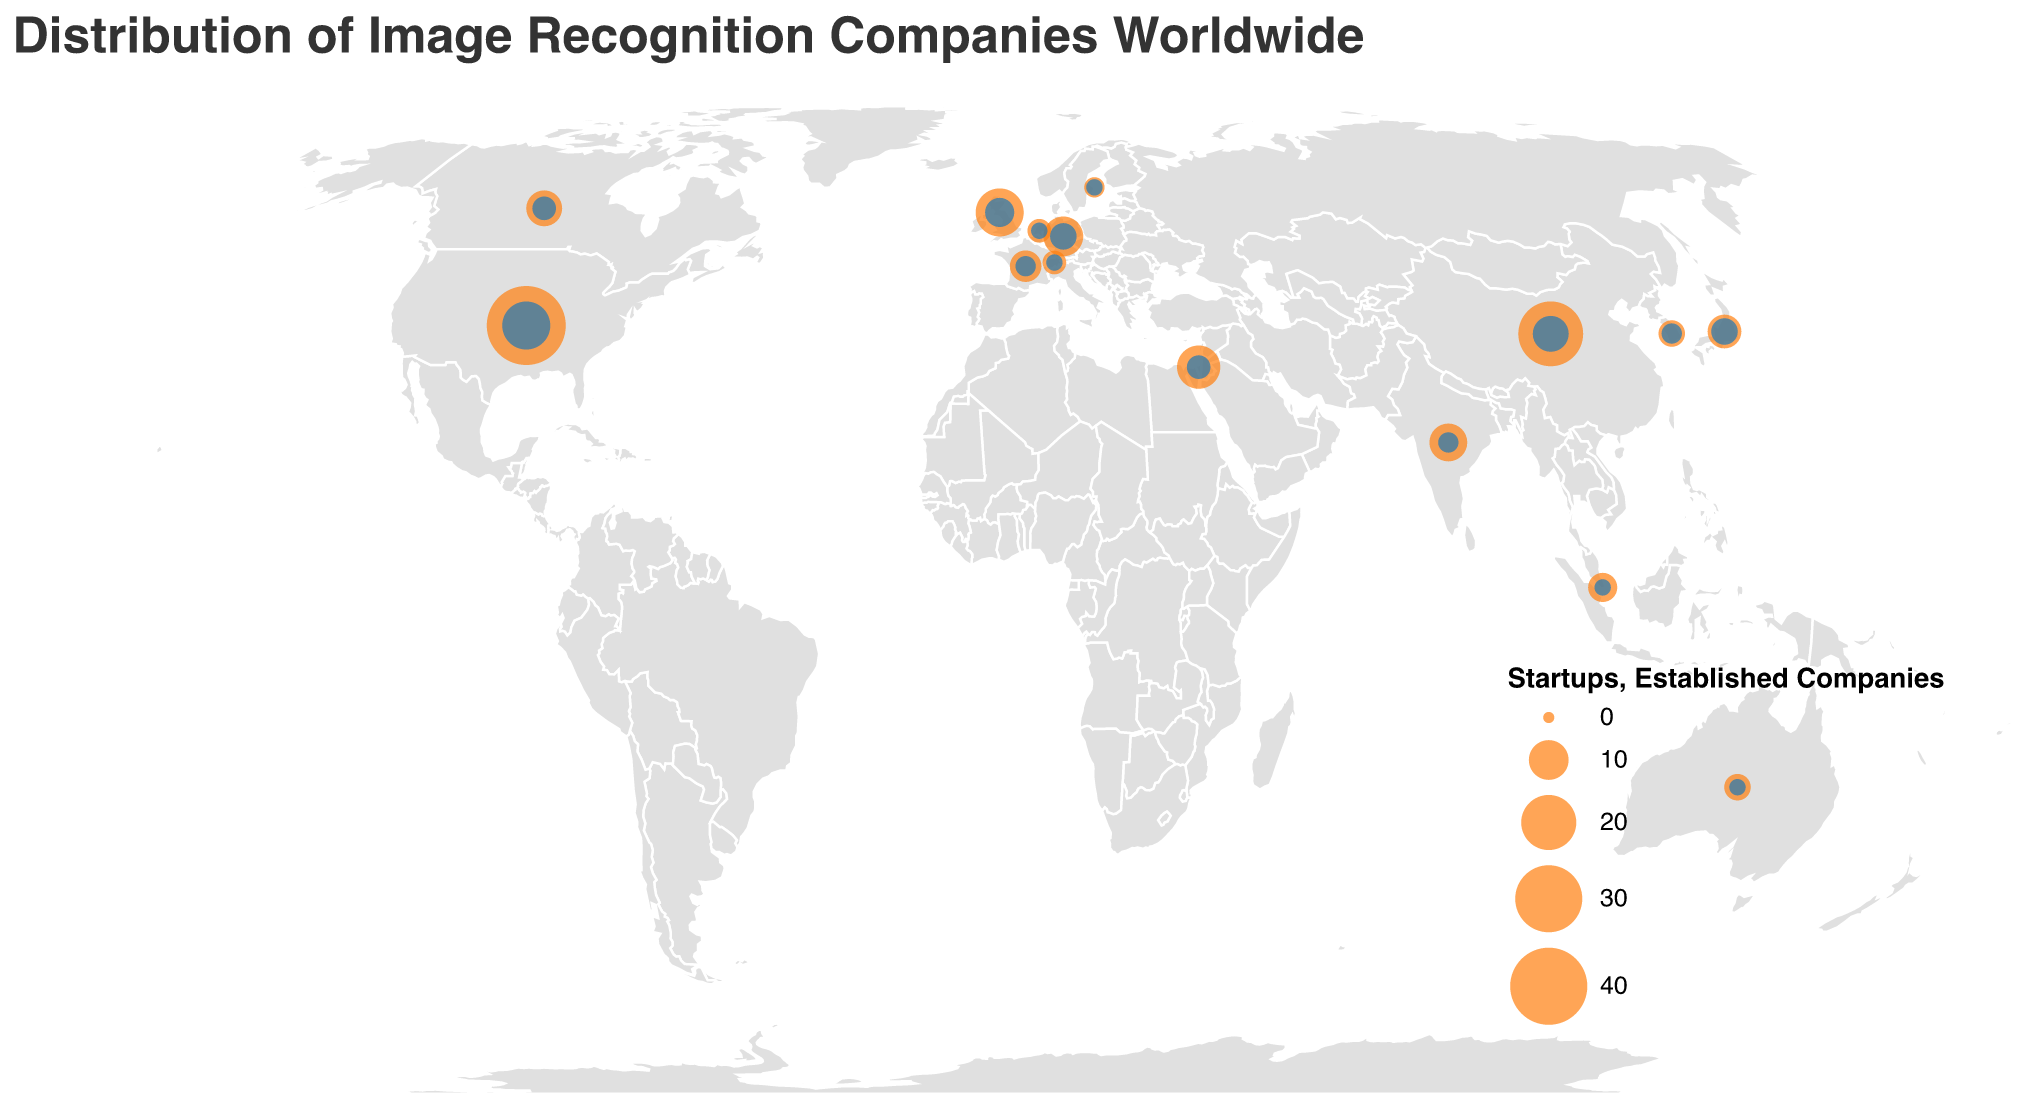What is the title of the plot? The title is displayed at the top of the plot in a larger font. It states the overall theme and context of the plot.
Answer: Distribution of Image Recognition Companies Worldwide Which country has the highest number of startups? By looking at the size of the orange circles (which represent the number of startups), the United States has the largest circle. The tooltip confirms it has 42 startups.
Answer: United States Which country has fewer established companies, India or Japan? Compare the blue circle sizes for India and Japan. The tooltip shows that India has 2 established companies while Japan has 4.
Answer: India How many more startups does the United States have compared to China? The number of startups in the United States is 42, and in China, it is 28. The difference is 42 - 28.
Answer: 14 What are the two countries with equal numbers of startups and established companies? Look for countries with the same number of startups as well as established companies in the tooltips or encoded values. Switzerland and the Netherlands both have 3 startups and 1 established company.
Answer: Switzerland, Netherlands Which country has the smallest presence in terms of startups and established companies combined? Look for the countries with the smallest circles, representing the least number of startups and established companies combined. Sweden has 2 startups and 1 established company, adding up to 3.
Answer: Sweden If you sum up the number of established companies in Israel, Germany, and Canada, what do you get? Sum the established companies: Israel (3), Germany (4), and Canada (3). The total is 3 + 4 + 3.
Answer: 10 Which continent shows a higher concentration of image recognition startups and established companies: North America or Europe? Compare the total number of startups and established companies in North America (United States and Canada) to Europe (United Kingdom, Germany, France, Netherlands, Switzerland, Sweden). North America has 57 (42+15) and Europe has 33 (15+5+10+4+6+2+3+1+2+1).
Answer: North America In Asia, which country has more established companies: China or India? By checking the blue circles and tooltips, China has 8 established companies and India has 2.
Answer: China 